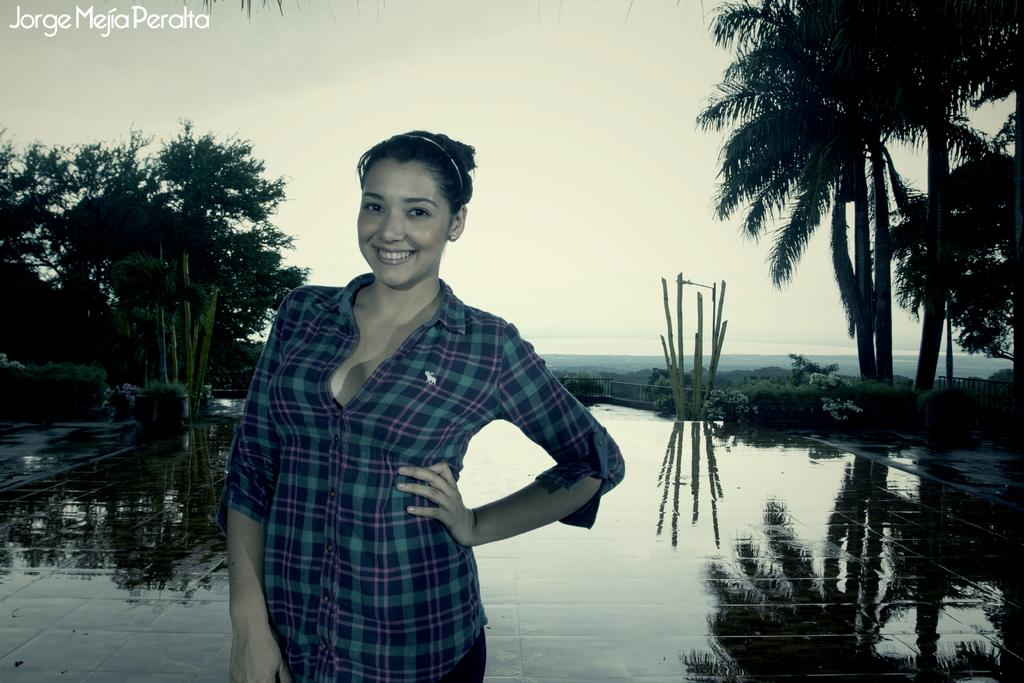What is the main subject of the image? There is a person standing in the image. Can you describe the person's clothing? The person is wearing a blue and green color shirt. What can be seen in the background of the image? There are plants and trees in the background of the image. What is visible in the sky in the image? The sky is visible in the image, and it appears to be white. What type of voice can be heard coming from the person in the image? There is no indication of any sound or voice in the image, as it is a still photograph. Is the person wearing a veil in the image? There is no mention of a veil in the image, and the person's clothing is described as a blue and green color shirt. 